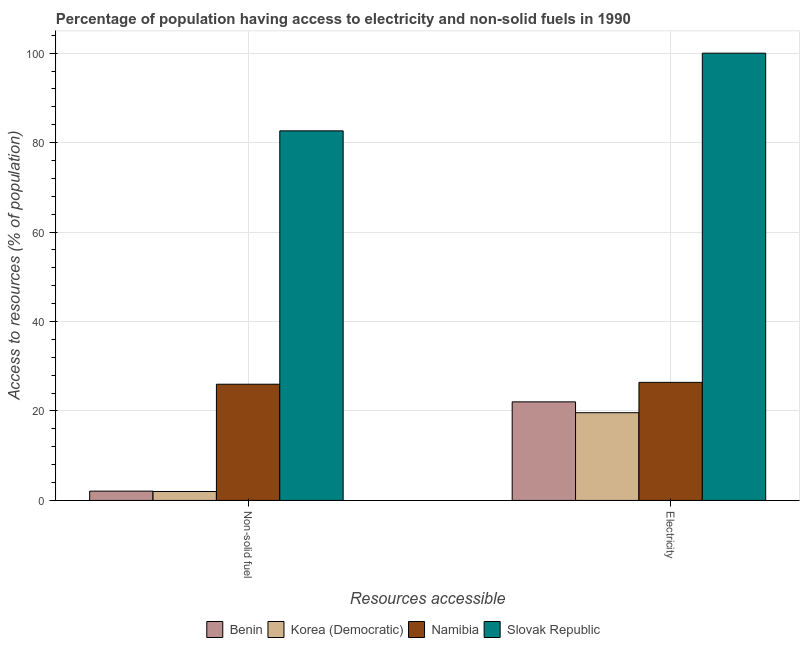How many groups of bars are there?
Offer a very short reply. 2. How many bars are there on the 2nd tick from the left?
Your answer should be compact. 4. How many bars are there on the 1st tick from the right?
Provide a short and direct response. 4. What is the label of the 1st group of bars from the left?
Give a very brief answer. Non-solid fuel. What is the percentage of population having access to non-solid fuel in Slovak Republic?
Your answer should be very brief. 82.63. Across all countries, what is the minimum percentage of population having access to electricity?
Your answer should be very brief. 19.62. In which country was the percentage of population having access to non-solid fuel maximum?
Your answer should be compact. Slovak Republic. In which country was the percentage of population having access to non-solid fuel minimum?
Give a very brief answer. Korea (Democratic). What is the total percentage of population having access to electricity in the graph?
Provide a short and direct response. 168.05. What is the difference between the percentage of population having access to non-solid fuel in Namibia and that in Benin?
Your response must be concise. 23.9. What is the difference between the percentage of population having access to non-solid fuel in Namibia and the percentage of population having access to electricity in Korea (Democratic)?
Your response must be concise. 6.37. What is the average percentage of population having access to electricity per country?
Ensure brevity in your answer.  42.01. What is the difference between the percentage of population having access to electricity and percentage of population having access to non-solid fuel in Benin?
Provide a short and direct response. 19.96. What is the ratio of the percentage of population having access to electricity in Benin to that in Korea (Democratic)?
Provide a succinct answer. 1.12. Is the percentage of population having access to non-solid fuel in Namibia less than that in Benin?
Give a very brief answer. No. What does the 3rd bar from the left in Electricity represents?
Your answer should be compact. Namibia. What does the 3rd bar from the right in Electricity represents?
Make the answer very short. Korea (Democratic). How many bars are there?
Provide a succinct answer. 8. How many countries are there in the graph?
Give a very brief answer. 4. Are the values on the major ticks of Y-axis written in scientific E-notation?
Provide a succinct answer. No. How many legend labels are there?
Your answer should be compact. 4. How are the legend labels stacked?
Your answer should be very brief. Horizontal. What is the title of the graph?
Your answer should be compact. Percentage of population having access to electricity and non-solid fuels in 1990. Does "Sao Tome and Principe" appear as one of the legend labels in the graph?
Provide a short and direct response. No. What is the label or title of the X-axis?
Offer a very short reply. Resources accessible. What is the label or title of the Y-axis?
Ensure brevity in your answer.  Access to resources (% of population). What is the Access to resources (% of population) of Benin in Non-solid fuel?
Ensure brevity in your answer.  2.08. What is the Access to resources (% of population) in Korea (Democratic) in Non-solid fuel?
Provide a succinct answer. 2. What is the Access to resources (% of population) in Namibia in Non-solid fuel?
Make the answer very short. 25.98. What is the Access to resources (% of population) of Slovak Republic in Non-solid fuel?
Your response must be concise. 82.63. What is the Access to resources (% of population) in Benin in Electricity?
Your answer should be compact. 22.04. What is the Access to resources (% of population) in Korea (Democratic) in Electricity?
Make the answer very short. 19.62. What is the Access to resources (% of population) of Namibia in Electricity?
Keep it short and to the point. 26.4. Across all Resources accessible, what is the maximum Access to resources (% of population) of Benin?
Your answer should be very brief. 22.04. Across all Resources accessible, what is the maximum Access to resources (% of population) of Korea (Democratic)?
Give a very brief answer. 19.62. Across all Resources accessible, what is the maximum Access to resources (% of population) of Namibia?
Your answer should be very brief. 26.4. Across all Resources accessible, what is the maximum Access to resources (% of population) of Slovak Republic?
Offer a terse response. 100. Across all Resources accessible, what is the minimum Access to resources (% of population) of Benin?
Offer a terse response. 2.08. Across all Resources accessible, what is the minimum Access to resources (% of population) in Korea (Democratic)?
Your answer should be very brief. 2. Across all Resources accessible, what is the minimum Access to resources (% of population) in Namibia?
Your response must be concise. 25.98. Across all Resources accessible, what is the minimum Access to resources (% of population) of Slovak Republic?
Offer a terse response. 82.63. What is the total Access to resources (% of population) of Benin in the graph?
Provide a succinct answer. 24.12. What is the total Access to resources (% of population) in Korea (Democratic) in the graph?
Provide a short and direct response. 21.62. What is the total Access to resources (% of population) of Namibia in the graph?
Your answer should be very brief. 52.38. What is the total Access to resources (% of population) of Slovak Republic in the graph?
Your answer should be compact. 182.63. What is the difference between the Access to resources (% of population) of Benin in Non-solid fuel and that in Electricity?
Make the answer very short. -19.96. What is the difference between the Access to resources (% of population) in Korea (Democratic) in Non-solid fuel and that in Electricity?
Your response must be concise. -17.62. What is the difference between the Access to resources (% of population) in Namibia in Non-solid fuel and that in Electricity?
Your response must be concise. -0.42. What is the difference between the Access to resources (% of population) in Slovak Republic in Non-solid fuel and that in Electricity?
Provide a succinct answer. -17.37. What is the difference between the Access to resources (% of population) in Benin in Non-solid fuel and the Access to resources (% of population) in Korea (Democratic) in Electricity?
Your response must be concise. -17.54. What is the difference between the Access to resources (% of population) in Benin in Non-solid fuel and the Access to resources (% of population) in Namibia in Electricity?
Keep it short and to the point. -24.32. What is the difference between the Access to resources (% of population) of Benin in Non-solid fuel and the Access to resources (% of population) of Slovak Republic in Electricity?
Keep it short and to the point. -97.92. What is the difference between the Access to resources (% of population) of Korea (Democratic) in Non-solid fuel and the Access to resources (% of population) of Namibia in Electricity?
Your response must be concise. -24.4. What is the difference between the Access to resources (% of population) of Korea (Democratic) in Non-solid fuel and the Access to resources (% of population) of Slovak Republic in Electricity?
Your answer should be very brief. -98. What is the difference between the Access to resources (% of population) of Namibia in Non-solid fuel and the Access to resources (% of population) of Slovak Republic in Electricity?
Make the answer very short. -74.02. What is the average Access to resources (% of population) in Benin per Resources accessible?
Your answer should be very brief. 12.06. What is the average Access to resources (% of population) in Korea (Democratic) per Resources accessible?
Ensure brevity in your answer.  10.81. What is the average Access to resources (% of population) in Namibia per Resources accessible?
Offer a terse response. 26.19. What is the average Access to resources (% of population) of Slovak Republic per Resources accessible?
Give a very brief answer. 91.32. What is the difference between the Access to resources (% of population) in Benin and Access to resources (% of population) in Korea (Democratic) in Non-solid fuel?
Your answer should be compact. 0.08. What is the difference between the Access to resources (% of population) in Benin and Access to resources (% of population) in Namibia in Non-solid fuel?
Ensure brevity in your answer.  -23.9. What is the difference between the Access to resources (% of population) in Benin and Access to resources (% of population) in Slovak Republic in Non-solid fuel?
Make the answer very short. -80.55. What is the difference between the Access to resources (% of population) in Korea (Democratic) and Access to resources (% of population) in Namibia in Non-solid fuel?
Your response must be concise. -23.98. What is the difference between the Access to resources (% of population) of Korea (Democratic) and Access to resources (% of population) of Slovak Republic in Non-solid fuel?
Provide a short and direct response. -80.63. What is the difference between the Access to resources (% of population) of Namibia and Access to resources (% of population) of Slovak Republic in Non-solid fuel?
Your answer should be compact. -56.65. What is the difference between the Access to resources (% of population) of Benin and Access to resources (% of population) of Korea (Democratic) in Electricity?
Offer a terse response. 2.42. What is the difference between the Access to resources (% of population) of Benin and Access to resources (% of population) of Namibia in Electricity?
Provide a succinct answer. -4.36. What is the difference between the Access to resources (% of population) in Benin and Access to resources (% of population) in Slovak Republic in Electricity?
Offer a terse response. -77.96. What is the difference between the Access to resources (% of population) of Korea (Democratic) and Access to resources (% of population) of Namibia in Electricity?
Make the answer very short. -6.78. What is the difference between the Access to resources (% of population) in Korea (Democratic) and Access to resources (% of population) in Slovak Republic in Electricity?
Provide a succinct answer. -80.38. What is the difference between the Access to resources (% of population) of Namibia and Access to resources (% of population) of Slovak Republic in Electricity?
Offer a very short reply. -73.6. What is the ratio of the Access to resources (% of population) of Benin in Non-solid fuel to that in Electricity?
Give a very brief answer. 0.09. What is the ratio of the Access to resources (% of population) of Korea (Democratic) in Non-solid fuel to that in Electricity?
Provide a short and direct response. 0.1. What is the ratio of the Access to resources (% of population) in Namibia in Non-solid fuel to that in Electricity?
Provide a succinct answer. 0.98. What is the ratio of the Access to resources (% of population) of Slovak Republic in Non-solid fuel to that in Electricity?
Make the answer very short. 0.83. What is the difference between the highest and the second highest Access to resources (% of population) in Benin?
Offer a very short reply. 19.96. What is the difference between the highest and the second highest Access to resources (% of population) in Korea (Democratic)?
Provide a succinct answer. 17.62. What is the difference between the highest and the second highest Access to resources (% of population) of Namibia?
Offer a terse response. 0.42. What is the difference between the highest and the second highest Access to resources (% of population) of Slovak Republic?
Your answer should be very brief. 17.37. What is the difference between the highest and the lowest Access to resources (% of population) of Benin?
Your answer should be very brief. 19.96. What is the difference between the highest and the lowest Access to resources (% of population) in Korea (Democratic)?
Your answer should be compact. 17.62. What is the difference between the highest and the lowest Access to resources (% of population) in Namibia?
Keep it short and to the point. 0.42. What is the difference between the highest and the lowest Access to resources (% of population) of Slovak Republic?
Your answer should be compact. 17.37. 